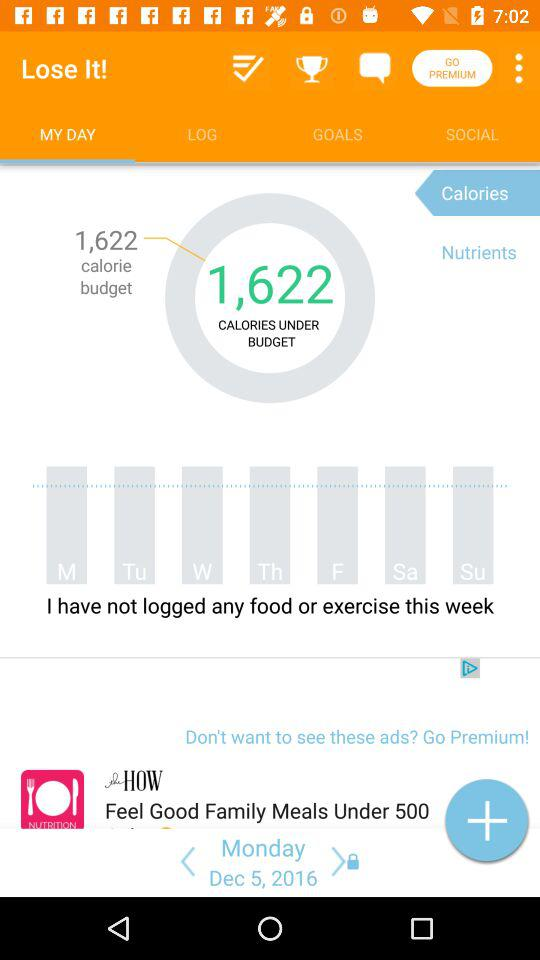How many calories are you under budget by?
Answer the question using a single word or phrase. 1,622 